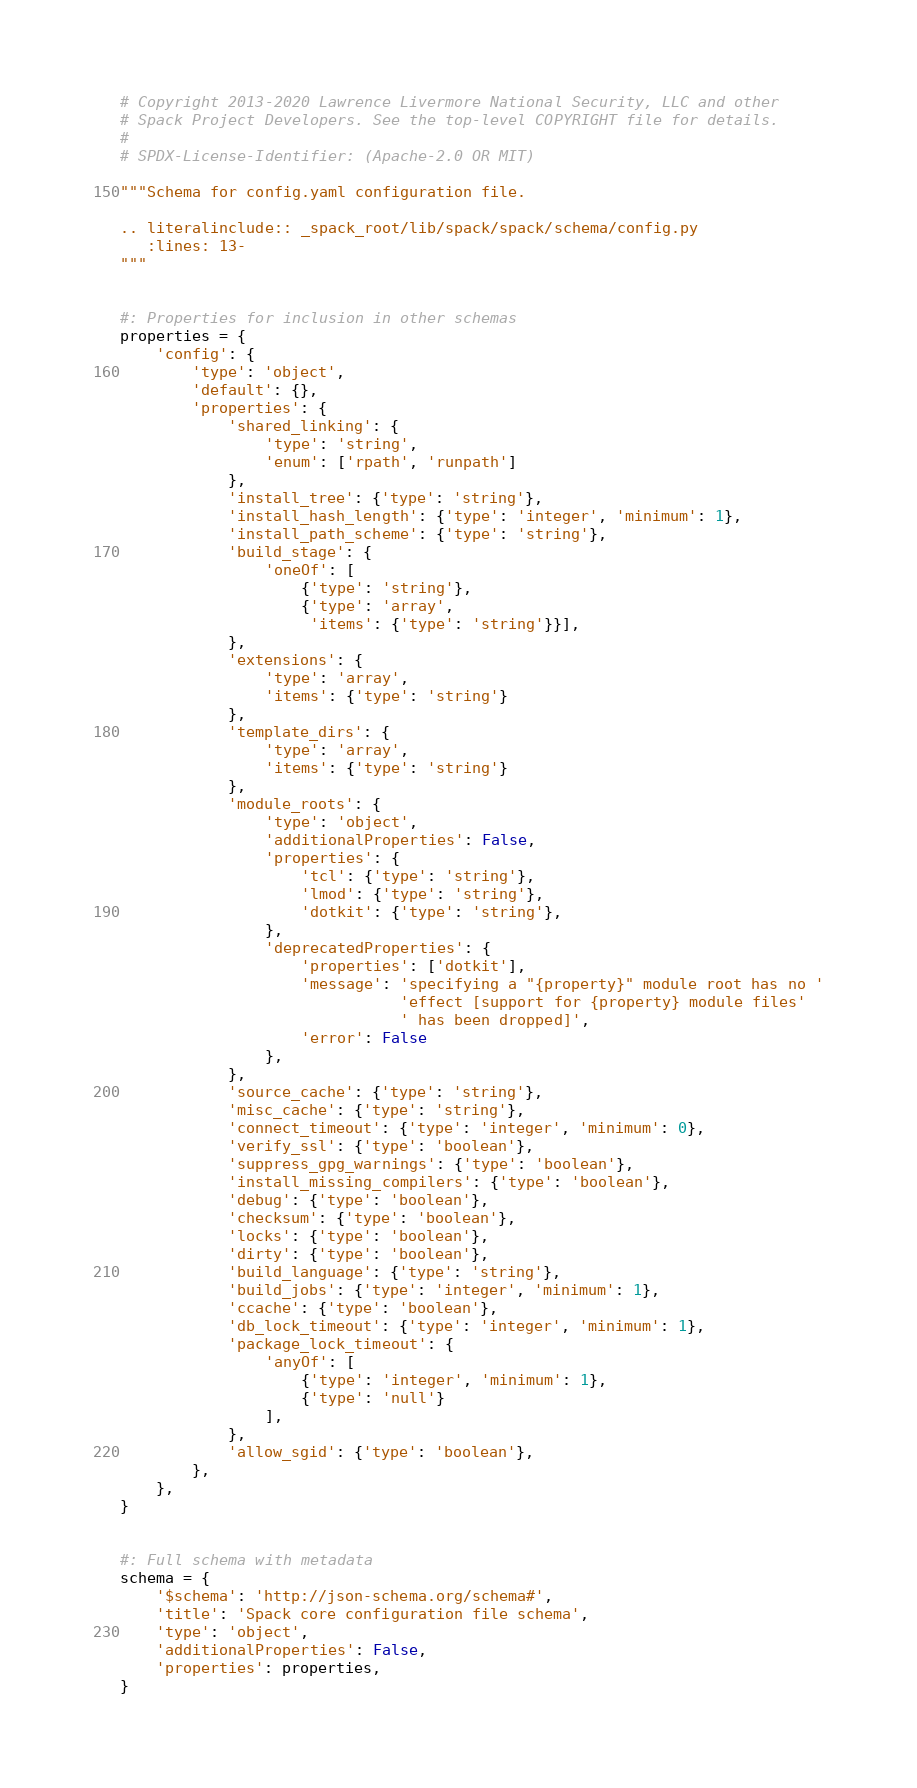<code> <loc_0><loc_0><loc_500><loc_500><_Python_># Copyright 2013-2020 Lawrence Livermore National Security, LLC and other
# Spack Project Developers. See the top-level COPYRIGHT file for details.
#
# SPDX-License-Identifier: (Apache-2.0 OR MIT)

"""Schema for config.yaml configuration file.

.. literalinclude:: _spack_root/lib/spack/spack/schema/config.py
   :lines: 13-
"""


#: Properties for inclusion in other schemas
properties = {
    'config': {
        'type': 'object',
        'default': {},
        'properties': {
            'shared_linking': {
                'type': 'string',
                'enum': ['rpath', 'runpath']
            },
            'install_tree': {'type': 'string'},
            'install_hash_length': {'type': 'integer', 'minimum': 1},
            'install_path_scheme': {'type': 'string'},
            'build_stage': {
                'oneOf': [
                    {'type': 'string'},
                    {'type': 'array',
                     'items': {'type': 'string'}}],
            },
            'extensions': {
                'type': 'array',
                'items': {'type': 'string'}
            },
            'template_dirs': {
                'type': 'array',
                'items': {'type': 'string'}
            },
            'module_roots': {
                'type': 'object',
                'additionalProperties': False,
                'properties': {
                    'tcl': {'type': 'string'},
                    'lmod': {'type': 'string'},
                    'dotkit': {'type': 'string'},
                },
                'deprecatedProperties': {
                    'properties': ['dotkit'],
                    'message': 'specifying a "{property}" module root has no '
                               'effect [support for {property} module files'
                               ' has been dropped]',
                    'error': False
                },
            },
            'source_cache': {'type': 'string'},
            'misc_cache': {'type': 'string'},
            'connect_timeout': {'type': 'integer', 'minimum': 0},
            'verify_ssl': {'type': 'boolean'},
            'suppress_gpg_warnings': {'type': 'boolean'},
            'install_missing_compilers': {'type': 'boolean'},
            'debug': {'type': 'boolean'},
            'checksum': {'type': 'boolean'},
            'locks': {'type': 'boolean'},
            'dirty': {'type': 'boolean'},
            'build_language': {'type': 'string'},
            'build_jobs': {'type': 'integer', 'minimum': 1},
            'ccache': {'type': 'boolean'},
            'db_lock_timeout': {'type': 'integer', 'minimum': 1},
            'package_lock_timeout': {
                'anyOf': [
                    {'type': 'integer', 'minimum': 1},
                    {'type': 'null'}
                ],
            },
            'allow_sgid': {'type': 'boolean'},
        },
    },
}


#: Full schema with metadata
schema = {
    '$schema': 'http://json-schema.org/schema#',
    'title': 'Spack core configuration file schema',
    'type': 'object',
    'additionalProperties': False,
    'properties': properties,
}
</code> 